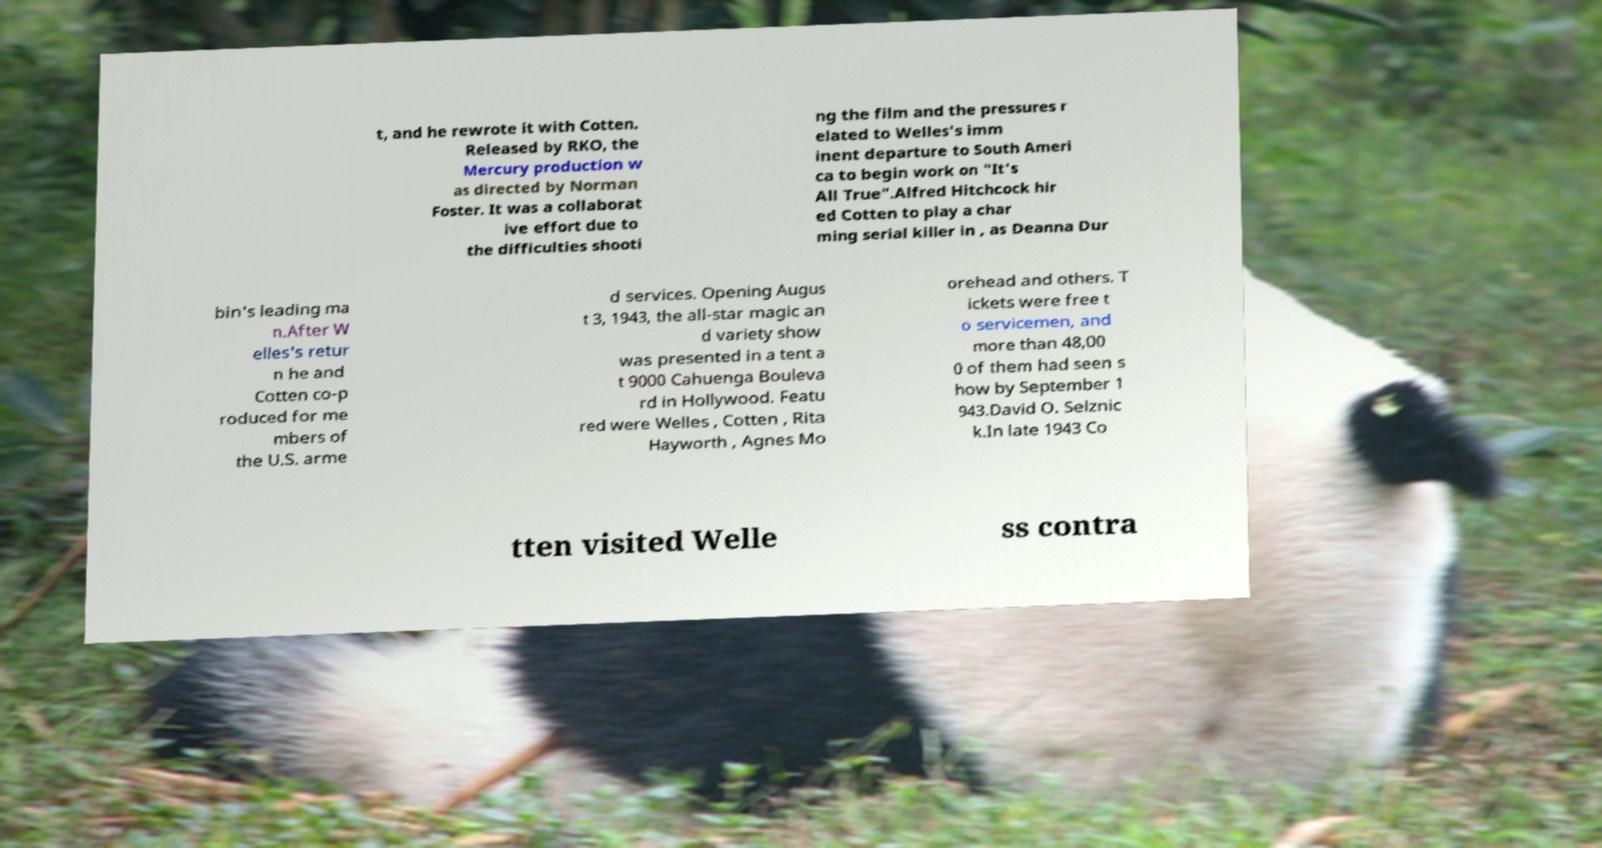Could you assist in decoding the text presented in this image and type it out clearly? t, and he rewrote it with Cotten. Released by RKO, the Mercury production w as directed by Norman Foster. It was a collaborat ive effort due to the difficulties shooti ng the film and the pressures r elated to Welles's imm inent departure to South Ameri ca to begin work on "It's All True".Alfred Hitchcock hir ed Cotten to play a char ming serial killer in , as Deanna Dur bin's leading ma n.After W elles's retur n he and Cotten co-p roduced for me mbers of the U.S. arme d services. Opening Augus t 3, 1943, the all-star magic an d variety show was presented in a tent a t 9000 Cahuenga Bouleva rd in Hollywood. Featu red were Welles , Cotten , Rita Hayworth , Agnes Mo orehead and others. T ickets were free t o servicemen, and more than 48,00 0 of them had seen s how by September 1 943.David O. Selznic k.In late 1943 Co tten visited Welle ss contra 